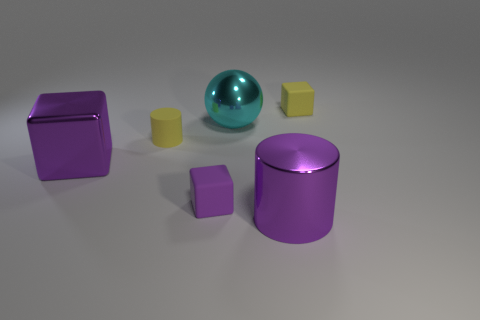How many large metallic things are the same color as the big cylinder?
Provide a short and direct response. 1. There is a big shiny thing in front of the purple metal object that is behind the purple cylinder; what is its color?
Provide a short and direct response. Purple. Is the material of the big cube the same as the yellow thing on the left side of the purple matte thing?
Keep it short and to the point. No. The small matte cube left of the rubber object that is on the right side of the big thing in front of the purple metal block is what color?
Offer a terse response. Purple. Is there any other thing that is the same shape as the cyan metal thing?
Provide a succinct answer. No. Is the number of purple matte objects greater than the number of tiny blue cylinders?
Offer a very short reply. Yes. How many purple metal objects are on the right side of the shiny cube and behind the large purple cylinder?
Your response must be concise. 0. What number of cubes are in front of the tiny yellow object that is on the right side of the large metal cylinder?
Your response must be concise. 2. There is a purple cube that is on the left side of the small purple object; is its size the same as the cylinder on the right side of the tiny yellow cylinder?
Your response must be concise. Yes. What number of tiny purple matte cylinders are there?
Make the answer very short. 0. 